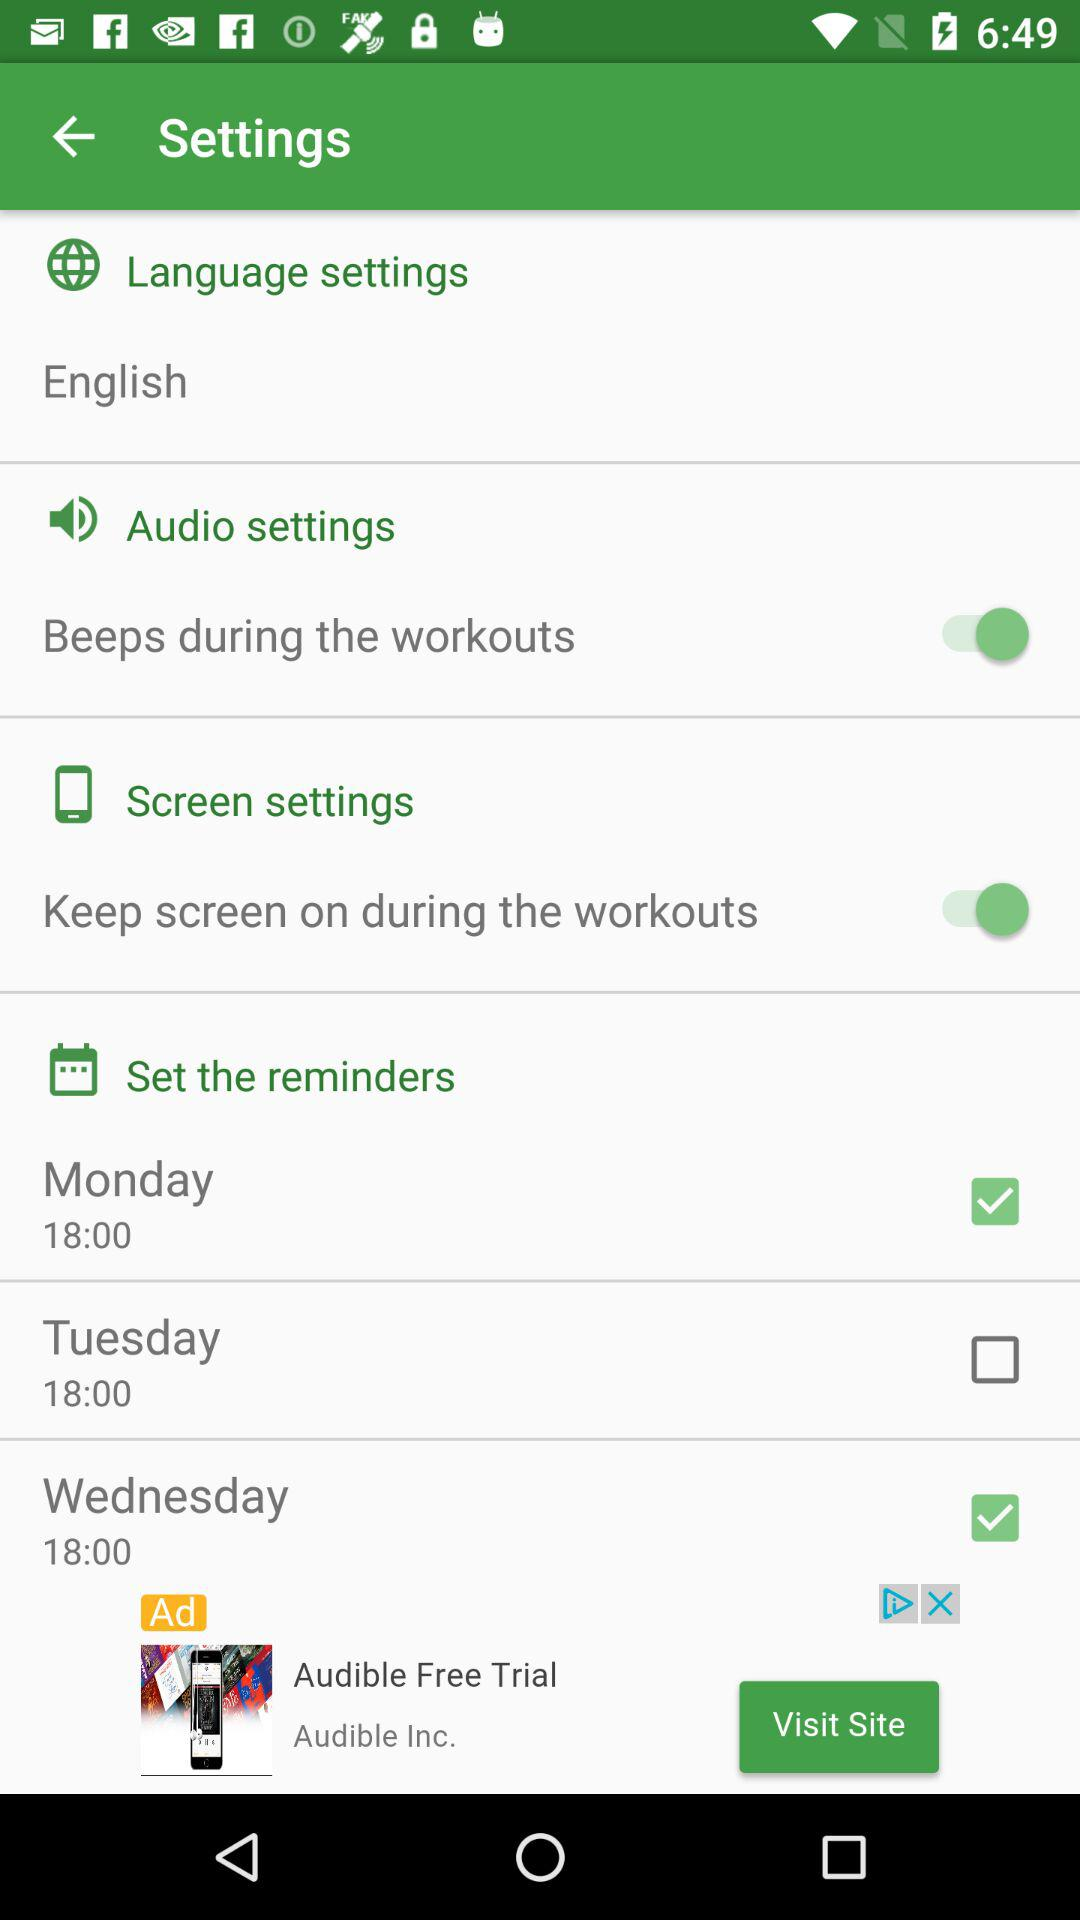What is the selected language? The selected language is English. 